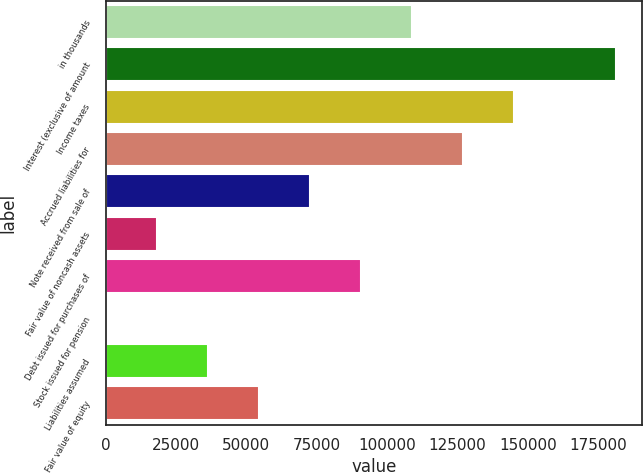<chart> <loc_0><loc_0><loc_500><loc_500><bar_chart><fcel>in thousands<fcel>Interest (exclusive of amount<fcel>Income taxes<fcel>Accrued liabilities for<fcel>Note received from sale of<fcel>Fair value of noncash assets<fcel>Debt issued for purchases of<fcel>Stock issued for pension<fcel>Liabilities assumed<fcel>Fair value of equity<nl><fcel>108812<fcel>181352<fcel>145082<fcel>126947<fcel>72541.3<fcel>18136<fcel>90676.4<fcel>0.83<fcel>36271.1<fcel>54406.2<nl></chart> 